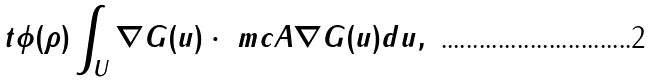<formula> <loc_0><loc_0><loc_500><loc_500>t \phi ( \rho ) \int _ { U } \nabla G ( u ) \cdot \ m c A \nabla G ( u ) d u ,</formula> 